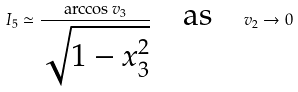<formula> <loc_0><loc_0><loc_500><loc_500>I _ { 5 } \simeq \frac { \arccos v _ { 3 } } { \sqrt { 1 - x _ { 3 } ^ { 2 } } } \quad \text {as} \quad v _ { 2 } \rightarrow 0</formula> 